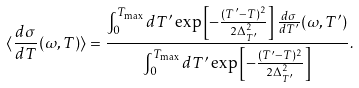<formula> <loc_0><loc_0><loc_500><loc_500>\langle \frac { d \sigma } { d T } ( \omega , T ) \rangle = \frac { \int _ { 0 } ^ { T _ { \max } } d T ^ { \prime } \exp \left [ - \frac { ( T ^ { \prime } - T ) ^ { 2 } } { 2 \Delta ^ { 2 } _ { T ^ { \prime } } } \right ] \frac { d \sigma } { d T ^ { \prime } } ( \omega , T ^ { \prime } ) } { \int _ { 0 } ^ { T _ { \max } } d T ^ { \prime } \exp \left [ - \frac { ( T ^ { \prime } - T ) ^ { 2 } } { 2 \Delta ^ { 2 } _ { T ^ { \prime } } } \right ] } .</formula> 